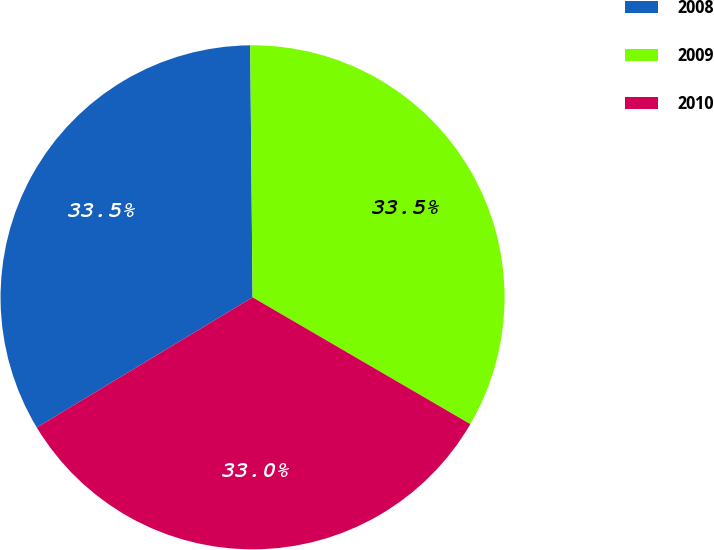Convert chart to OTSL. <chart><loc_0><loc_0><loc_500><loc_500><pie_chart><fcel>2008<fcel>2009<fcel>2010<nl><fcel>33.49%<fcel>33.54%<fcel>32.97%<nl></chart> 